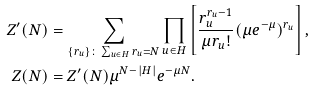Convert formula to latex. <formula><loc_0><loc_0><loc_500><loc_500>Z ^ { \prime } ( N ) & = \sum _ { \{ r _ { u } \} \colon \sum _ { u \in H } r _ { u } = N } \prod _ { u \in H } \left [ \frac { r _ { u } ^ { r _ { u } - 1 } } { \mu r _ { u } ! } ( \mu e ^ { - \mu } ) ^ { r _ { u } } \right ] , \\ Z ( N ) & = Z ^ { \prime } ( N ) \mu ^ { N - | H | } e ^ { - \mu N } .</formula> 